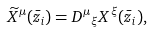Convert formula to latex. <formula><loc_0><loc_0><loc_500><loc_500>\widetilde { X } ^ { \mu } ( \bar { z } _ { i } ) = { D ^ { \mu } } _ { \xi } X ^ { \xi } ( \bar { z } _ { i } ) ,</formula> 